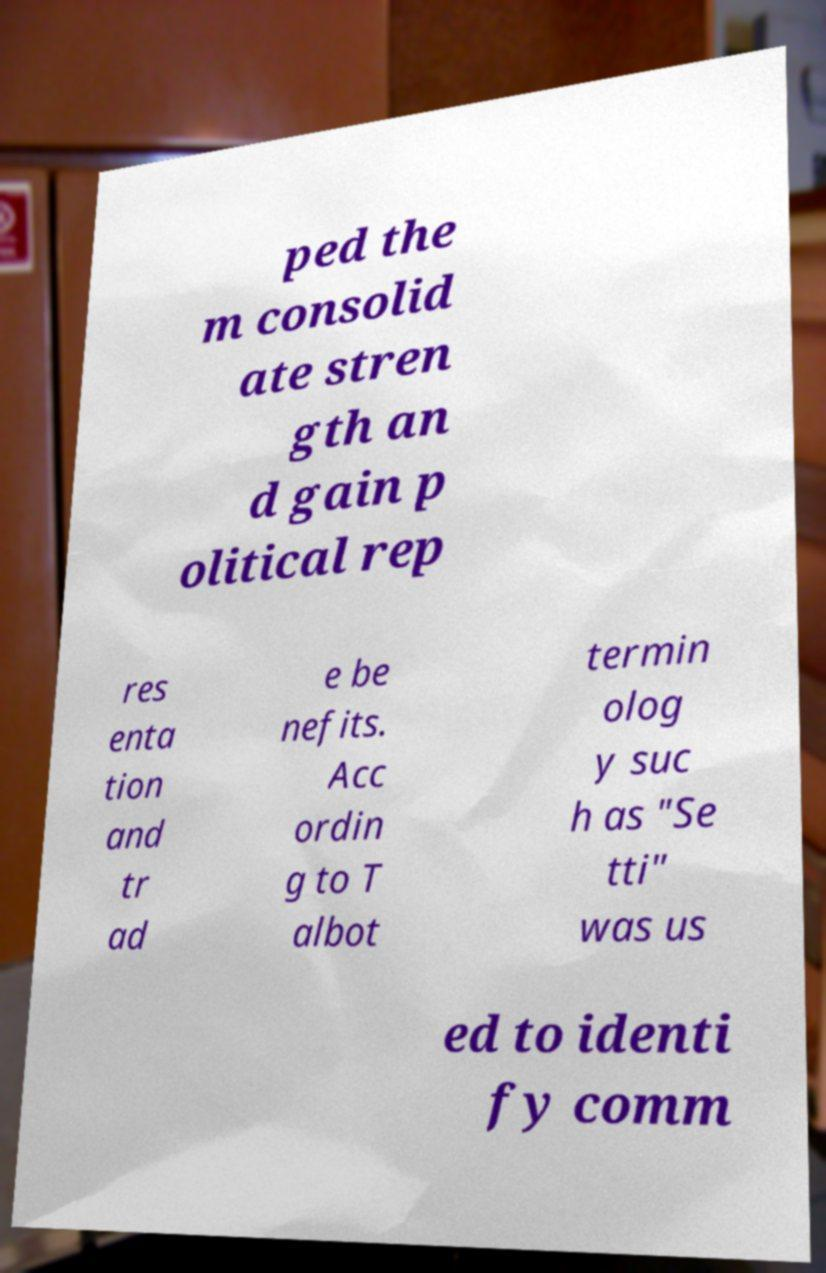What messages or text are displayed in this image? I need them in a readable, typed format. ped the m consolid ate stren gth an d gain p olitical rep res enta tion and tr ad e be nefits. Acc ordin g to T albot termin olog y suc h as "Se tti" was us ed to identi fy comm 